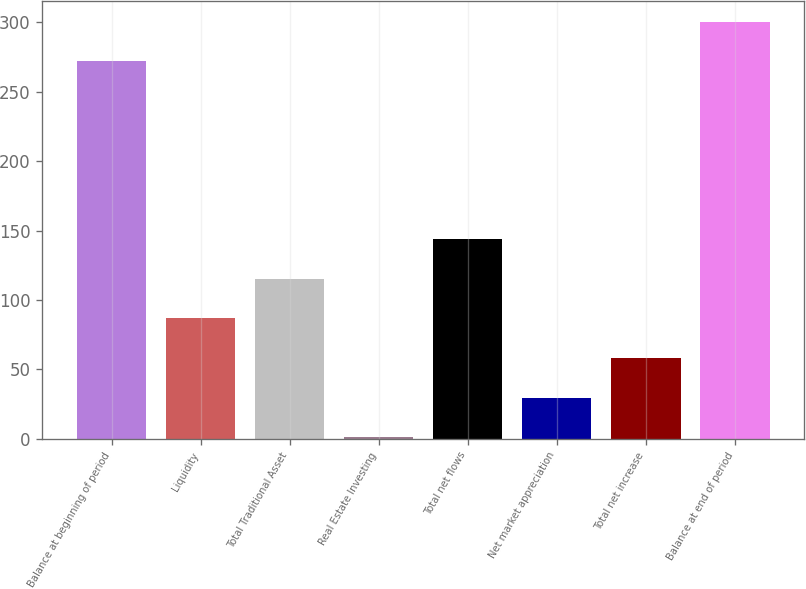Convert chart to OTSL. <chart><loc_0><loc_0><loc_500><loc_500><bar_chart><fcel>Balance at beginning of period<fcel>Liquidity<fcel>Total Traditional Asset<fcel>Real Estate Investing<fcel>Total net flows<fcel>Net market appreciation<fcel>Total net increase<fcel>Balance at end of period<nl><fcel>272<fcel>86.8<fcel>115.4<fcel>1<fcel>144<fcel>29.6<fcel>58.2<fcel>300.6<nl></chart> 